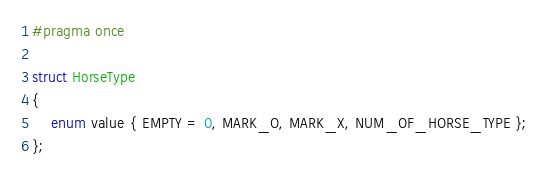Convert code to text. <code><loc_0><loc_0><loc_500><loc_500><_C_>#pragma once

struct HorseType
{
	enum value { EMPTY = 0, MARK_O, MARK_X, NUM_OF_HORSE_TYPE };
};</code> 